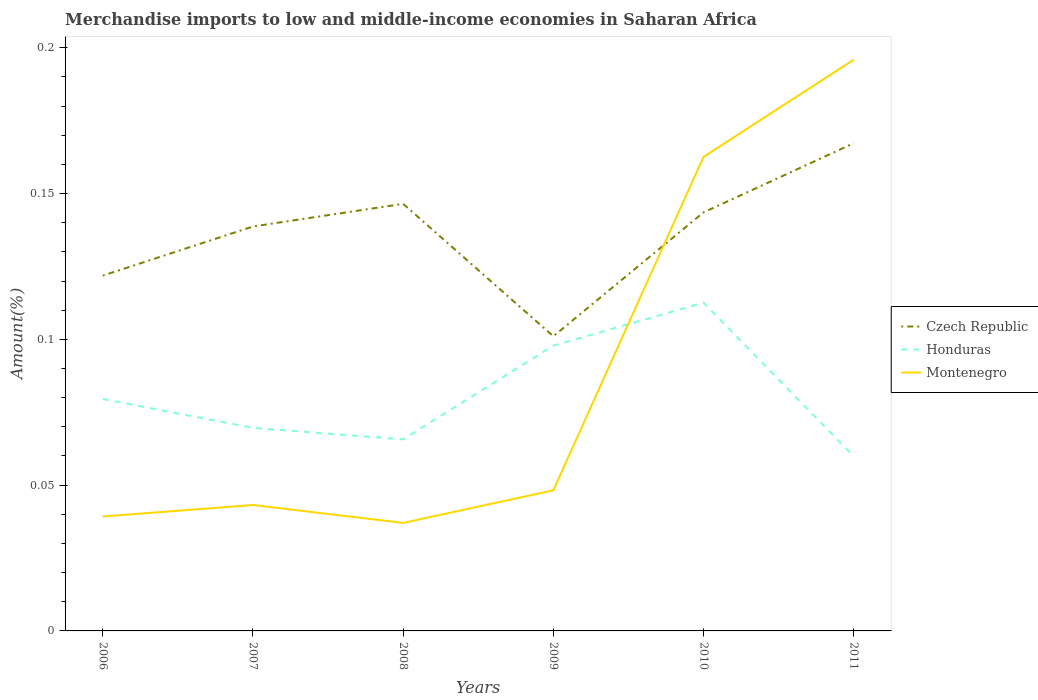How many different coloured lines are there?
Ensure brevity in your answer.  3. Across all years, what is the maximum percentage of amount earned from merchandise imports in Honduras?
Provide a short and direct response. 0.06. What is the total percentage of amount earned from merchandise imports in Czech Republic in the graph?
Your response must be concise. 0.05. What is the difference between the highest and the second highest percentage of amount earned from merchandise imports in Honduras?
Your answer should be compact. 0.05. What is the difference between the highest and the lowest percentage of amount earned from merchandise imports in Montenegro?
Your answer should be compact. 2. Is the percentage of amount earned from merchandise imports in Honduras strictly greater than the percentage of amount earned from merchandise imports in Montenegro over the years?
Ensure brevity in your answer.  No. How many lines are there?
Make the answer very short. 3. Are the values on the major ticks of Y-axis written in scientific E-notation?
Provide a succinct answer. No. Does the graph contain any zero values?
Give a very brief answer. No. Where does the legend appear in the graph?
Your response must be concise. Center right. How many legend labels are there?
Offer a very short reply. 3. How are the legend labels stacked?
Give a very brief answer. Vertical. What is the title of the graph?
Your answer should be very brief. Merchandise imports to low and middle-income economies in Saharan Africa. Does "Gambia, The" appear as one of the legend labels in the graph?
Provide a succinct answer. No. What is the label or title of the X-axis?
Provide a short and direct response. Years. What is the label or title of the Y-axis?
Your answer should be very brief. Amount(%). What is the Amount(%) in Czech Republic in 2006?
Make the answer very short. 0.12. What is the Amount(%) of Honduras in 2006?
Your response must be concise. 0.08. What is the Amount(%) in Montenegro in 2006?
Your response must be concise. 0.04. What is the Amount(%) of Czech Republic in 2007?
Provide a short and direct response. 0.14. What is the Amount(%) of Honduras in 2007?
Ensure brevity in your answer.  0.07. What is the Amount(%) in Montenegro in 2007?
Provide a succinct answer. 0.04. What is the Amount(%) of Czech Republic in 2008?
Your response must be concise. 0.15. What is the Amount(%) of Honduras in 2008?
Your answer should be compact. 0.07. What is the Amount(%) of Montenegro in 2008?
Offer a very short reply. 0.04. What is the Amount(%) of Czech Republic in 2009?
Keep it short and to the point. 0.1. What is the Amount(%) in Honduras in 2009?
Your answer should be compact. 0.1. What is the Amount(%) of Montenegro in 2009?
Your response must be concise. 0.05. What is the Amount(%) of Czech Republic in 2010?
Your answer should be very brief. 0.14. What is the Amount(%) in Honduras in 2010?
Provide a succinct answer. 0.11. What is the Amount(%) in Montenegro in 2010?
Give a very brief answer. 0.16. What is the Amount(%) in Czech Republic in 2011?
Provide a succinct answer. 0.17. What is the Amount(%) of Honduras in 2011?
Ensure brevity in your answer.  0.06. What is the Amount(%) of Montenegro in 2011?
Make the answer very short. 0.2. Across all years, what is the maximum Amount(%) of Czech Republic?
Give a very brief answer. 0.17. Across all years, what is the maximum Amount(%) of Honduras?
Offer a terse response. 0.11. Across all years, what is the maximum Amount(%) of Montenegro?
Ensure brevity in your answer.  0.2. Across all years, what is the minimum Amount(%) of Czech Republic?
Your answer should be very brief. 0.1. Across all years, what is the minimum Amount(%) in Honduras?
Provide a short and direct response. 0.06. Across all years, what is the minimum Amount(%) in Montenegro?
Give a very brief answer. 0.04. What is the total Amount(%) of Czech Republic in the graph?
Your response must be concise. 0.82. What is the total Amount(%) of Honduras in the graph?
Provide a succinct answer. 0.49. What is the total Amount(%) of Montenegro in the graph?
Your response must be concise. 0.53. What is the difference between the Amount(%) in Czech Republic in 2006 and that in 2007?
Your answer should be compact. -0.02. What is the difference between the Amount(%) in Honduras in 2006 and that in 2007?
Keep it short and to the point. 0.01. What is the difference between the Amount(%) of Montenegro in 2006 and that in 2007?
Provide a short and direct response. -0. What is the difference between the Amount(%) of Czech Republic in 2006 and that in 2008?
Provide a short and direct response. -0.02. What is the difference between the Amount(%) in Honduras in 2006 and that in 2008?
Provide a succinct answer. 0.01. What is the difference between the Amount(%) in Montenegro in 2006 and that in 2008?
Offer a terse response. 0. What is the difference between the Amount(%) in Czech Republic in 2006 and that in 2009?
Give a very brief answer. 0.02. What is the difference between the Amount(%) of Honduras in 2006 and that in 2009?
Give a very brief answer. -0.02. What is the difference between the Amount(%) in Montenegro in 2006 and that in 2009?
Your response must be concise. -0.01. What is the difference between the Amount(%) in Czech Republic in 2006 and that in 2010?
Ensure brevity in your answer.  -0.02. What is the difference between the Amount(%) of Honduras in 2006 and that in 2010?
Your answer should be very brief. -0.03. What is the difference between the Amount(%) of Montenegro in 2006 and that in 2010?
Give a very brief answer. -0.12. What is the difference between the Amount(%) of Czech Republic in 2006 and that in 2011?
Ensure brevity in your answer.  -0.05. What is the difference between the Amount(%) of Honduras in 2006 and that in 2011?
Your answer should be very brief. 0.02. What is the difference between the Amount(%) of Montenegro in 2006 and that in 2011?
Your answer should be compact. -0.16. What is the difference between the Amount(%) in Czech Republic in 2007 and that in 2008?
Make the answer very short. -0.01. What is the difference between the Amount(%) of Honduras in 2007 and that in 2008?
Your response must be concise. 0. What is the difference between the Amount(%) of Montenegro in 2007 and that in 2008?
Your answer should be compact. 0.01. What is the difference between the Amount(%) in Czech Republic in 2007 and that in 2009?
Provide a short and direct response. 0.04. What is the difference between the Amount(%) of Honduras in 2007 and that in 2009?
Provide a succinct answer. -0.03. What is the difference between the Amount(%) of Montenegro in 2007 and that in 2009?
Offer a terse response. -0.01. What is the difference between the Amount(%) in Czech Republic in 2007 and that in 2010?
Give a very brief answer. -0. What is the difference between the Amount(%) of Honduras in 2007 and that in 2010?
Your answer should be compact. -0.04. What is the difference between the Amount(%) of Montenegro in 2007 and that in 2010?
Offer a very short reply. -0.12. What is the difference between the Amount(%) in Czech Republic in 2007 and that in 2011?
Your answer should be very brief. -0.03. What is the difference between the Amount(%) in Honduras in 2007 and that in 2011?
Your response must be concise. 0.01. What is the difference between the Amount(%) of Montenegro in 2007 and that in 2011?
Ensure brevity in your answer.  -0.15. What is the difference between the Amount(%) in Czech Republic in 2008 and that in 2009?
Offer a very short reply. 0.05. What is the difference between the Amount(%) in Honduras in 2008 and that in 2009?
Provide a short and direct response. -0.03. What is the difference between the Amount(%) in Montenegro in 2008 and that in 2009?
Your response must be concise. -0.01. What is the difference between the Amount(%) of Czech Republic in 2008 and that in 2010?
Ensure brevity in your answer.  0. What is the difference between the Amount(%) of Honduras in 2008 and that in 2010?
Provide a succinct answer. -0.05. What is the difference between the Amount(%) in Montenegro in 2008 and that in 2010?
Keep it short and to the point. -0.13. What is the difference between the Amount(%) of Czech Republic in 2008 and that in 2011?
Offer a terse response. -0.02. What is the difference between the Amount(%) in Honduras in 2008 and that in 2011?
Ensure brevity in your answer.  0.01. What is the difference between the Amount(%) of Montenegro in 2008 and that in 2011?
Offer a terse response. -0.16. What is the difference between the Amount(%) of Czech Republic in 2009 and that in 2010?
Your answer should be very brief. -0.04. What is the difference between the Amount(%) of Honduras in 2009 and that in 2010?
Make the answer very short. -0.01. What is the difference between the Amount(%) of Montenegro in 2009 and that in 2010?
Provide a succinct answer. -0.11. What is the difference between the Amount(%) in Czech Republic in 2009 and that in 2011?
Your response must be concise. -0.07. What is the difference between the Amount(%) of Honduras in 2009 and that in 2011?
Make the answer very short. 0.04. What is the difference between the Amount(%) in Montenegro in 2009 and that in 2011?
Your answer should be very brief. -0.15. What is the difference between the Amount(%) in Czech Republic in 2010 and that in 2011?
Your answer should be very brief. -0.02. What is the difference between the Amount(%) in Honduras in 2010 and that in 2011?
Provide a succinct answer. 0.05. What is the difference between the Amount(%) of Montenegro in 2010 and that in 2011?
Give a very brief answer. -0.03. What is the difference between the Amount(%) of Czech Republic in 2006 and the Amount(%) of Honduras in 2007?
Offer a terse response. 0.05. What is the difference between the Amount(%) of Czech Republic in 2006 and the Amount(%) of Montenegro in 2007?
Your answer should be compact. 0.08. What is the difference between the Amount(%) of Honduras in 2006 and the Amount(%) of Montenegro in 2007?
Make the answer very short. 0.04. What is the difference between the Amount(%) of Czech Republic in 2006 and the Amount(%) of Honduras in 2008?
Offer a terse response. 0.06. What is the difference between the Amount(%) of Czech Republic in 2006 and the Amount(%) of Montenegro in 2008?
Keep it short and to the point. 0.08. What is the difference between the Amount(%) of Honduras in 2006 and the Amount(%) of Montenegro in 2008?
Ensure brevity in your answer.  0.04. What is the difference between the Amount(%) of Czech Republic in 2006 and the Amount(%) of Honduras in 2009?
Keep it short and to the point. 0.02. What is the difference between the Amount(%) in Czech Republic in 2006 and the Amount(%) in Montenegro in 2009?
Keep it short and to the point. 0.07. What is the difference between the Amount(%) of Honduras in 2006 and the Amount(%) of Montenegro in 2009?
Provide a succinct answer. 0.03. What is the difference between the Amount(%) in Czech Republic in 2006 and the Amount(%) in Honduras in 2010?
Make the answer very short. 0.01. What is the difference between the Amount(%) in Czech Republic in 2006 and the Amount(%) in Montenegro in 2010?
Give a very brief answer. -0.04. What is the difference between the Amount(%) in Honduras in 2006 and the Amount(%) in Montenegro in 2010?
Give a very brief answer. -0.08. What is the difference between the Amount(%) in Czech Republic in 2006 and the Amount(%) in Honduras in 2011?
Keep it short and to the point. 0.06. What is the difference between the Amount(%) in Czech Republic in 2006 and the Amount(%) in Montenegro in 2011?
Your answer should be very brief. -0.07. What is the difference between the Amount(%) in Honduras in 2006 and the Amount(%) in Montenegro in 2011?
Make the answer very short. -0.12. What is the difference between the Amount(%) of Czech Republic in 2007 and the Amount(%) of Honduras in 2008?
Make the answer very short. 0.07. What is the difference between the Amount(%) in Czech Republic in 2007 and the Amount(%) in Montenegro in 2008?
Your answer should be very brief. 0.1. What is the difference between the Amount(%) of Honduras in 2007 and the Amount(%) of Montenegro in 2008?
Offer a terse response. 0.03. What is the difference between the Amount(%) in Czech Republic in 2007 and the Amount(%) in Honduras in 2009?
Your answer should be compact. 0.04. What is the difference between the Amount(%) of Czech Republic in 2007 and the Amount(%) of Montenegro in 2009?
Your answer should be very brief. 0.09. What is the difference between the Amount(%) in Honduras in 2007 and the Amount(%) in Montenegro in 2009?
Provide a short and direct response. 0.02. What is the difference between the Amount(%) in Czech Republic in 2007 and the Amount(%) in Honduras in 2010?
Keep it short and to the point. 0.03. What is the difference between the Amount(%) of Czech Republic in 2007 and the Amount(%) of Montenegro in 2010?
Keep it short and to the point. -0.02. What is the difference between the Amount(%) in Honduras in 2007 and the Amount(%) in Montenegro in 2010?
Ensure brevity in your answer.  -0.09. What is the difference between the Amount(%) in Czech Republic in 2007 and the Amount(%) in Honduras in 2011?
Give a very brief answer. 0.08. What is the difference between the Amount(%) in Czech Republic in 2007 and the Amount(%) in Montenegro in 2011?
Make the answer very short. -0.06. What is the difference between the Amount(%) of Honduras in 2007 and the Amount(%) of Montenegro in 2011?
Make the answer very short. -0.13. What is the difference between the Amount(%) of Czech Republic in 2008 and the Amount(%) of Honduras in 2009?
Your response must be concise. 0.05. What is the difference between the Amount(%) of Czech Republic in 2008 and the Amount(%) of Montenegro in 2009?
Your answer should be compact. 0.1. What is the difference between the Amount(%) in Honduras in 2008 and the Amount(%) in Montenegro in 2009?
Provide a short and direct response. 0.02. What is the difference between the Amount(%) in Czech Republic in 2008 and the Amount(%) in Honduras in 2010?
Ensure brevity in your answer.  0.03. What is the difference between the Amount(%) of Czech Republic in 2008 and the Amount(%) of Montenegro in 2010?
Your answer should be compact. -0.02. What is the difference between the Amount(%) in Honduras in 2008 and the Amount(%) in Montenegro in 2010?
Provide a succinct answer. -0.1. What is the difference between the Amount(%) in Czech Republic in 2008 and the Amount(%) in Honduras in 2011?
Your answer should be compact. 0.09. What is the difference between the Amount(%) of Czech Republic in 2008 and the Amount(%) of Montenegro in 2011?
Make the answer very short. -0.05. What is the difference between the Amount(%) in Honduras in 2008 and the Amount(%) in Montenegro in 2011?
Keep it short and to the point. -0.13. What is the difference between the Amount(%) in Czech Republic in 2009 and the Amount(%) in Honduras in 2010?
Make the answer very short. -0.01. What is the difference between the Amount(%) in Czech Republic in 2009 and the Amount(%) in Montenegro in 2010?
Your answer should be compact. -0.06. What is the difference between the Amount(%) of Honduras in 2009 and the Amount(%) of Montenegro in 2010?
Make the answer very short. -0.06. What is the difference between the Amount(%) of Czech Republic in 2009 and the Amount(%) of Honduras in 2011?
Offer a terse response. 0.04. What is the difference between the Amount(%) in Czech Republic in 2009 and the Amount(%) in Montenegro in 2011?
Keep it short and to the point. -0.09. What is the difference between the Amount(%) in Honduras in 2009 and the Amount(%) in Montenegro in 2011?
Provide a succinct answer. -0.1. What is the difference between the Amount(%) of Czech Republic in 2010 and the Amount(%) of Honduras in 2011?
Ensure brevity in your answer.  0.08. What is the difference between the Amount(%) of Czech Republic in 2010 and the Amount(%) of Montenegro in 2011?
Ensure brevity in your answer.  -0.05. What is the difference between the Amount(%) in Honduras in 2010 and the Amount(%) in Montenegro in 2011?
Ensure brevity in your answer.  -0.08. What is the average Amount(%) of Czech Republic per year?
Provide a short and direct response. 0.14. What is the average Amount(%) in Honduras per year?
Provide a short and direct response. 0.08. What is the average Amount(%) in Montenegro per year?
Your response must be concise. 0.09. In the year 2006, what is the difference between the Amount(%) of Czech Republic and Amount(%) of Honduras?
Offer a terse response. 0.04. In the year 2006, what is the difference between the Amount(%) of Czech Republic and Amount(%) of Montenegro?
Offer a very short reply. 0.08. In the year 2006, what is the difference between the Amount(%) of Honduras and Amount(%) of Montenegro?
Keep it short and to the point. 0.04. In the year 2007, what is the difference between the Amount(%) in Czech Republic and Amount(%) in Honduras?
Make the answer very short. 0.07. In the year 2007, what is the difference between the Amount(%) of Czech Republic and Amount(%) of Montenegro?
Offer a very short reply. 0.1. In the year 2007, what is the difference between the Amount(%) in Honduras and Amount(%) in Montenegro?
Your answer should be very brief. 0.03. In the year 2008, what is the difference between the Amount(%) of Czech Republic and Amount(%) of Honduras?
Keep it short and to the point. 0.08. In the year 2008, what is the difference between the Amount(%) of Czech Republic and Amount(%) of Montenegro?
Your answer should be compact. 0.11. In the year 2008, what is the difference between the Amount(%) of Honduras and Amount(%) of Montenegro?
Make the answer very short. 0.03. In the year 2009, what is the difference between the Amount(%) in Czech Republic and Amount(%) in Honduras?
Ensure brevity in your answer.  0. In the year 2009, what is the difference between the Amount(%) of Czech Republic and Amount(%) of Montenegro?
Your response must be concise. 0.05. In the year 2009, what is the difference between the Amount(%) of Honduras and Amount(%) of Montenegro?
Your answer should be very brief. 0.05. In the year 2010, what is the difference between the Amount(%) in Czech Republic and Amount(%) in Honduras?
Keep it short and to the point. 0.03. In the year 2010, what is the difference between the Amount(%) in Czech Republic and Amount(%) in Montenegro?
Make the answer very short. -0.02. In the year 2010, what is the difference between the Amount(%) of Honduras and Amount(%) of Montenegro?
Ensure brevity in your answer.  -0.05. In the year 2011, what is the difference between the Amount(%) of Czech Republic and Amount(%) of Honduras?
Provide a short and direct response. 0.11. In the year 2011, what is the difference between the Amount(%) in Czech Republic and Amount(%) in Montenegro?
Ensure brevity in your answer.  -0.03. In the year 2011, what is the difference between the Amount(%) of Honduras and Amount(%) of Montenegro?
Keep it short and to the point. -0.14. What is the ratio of the Amount(%) in Czech Republic in 2006 to that in 2007?
Your answer should be very brief. 0.88. What is the ratio of the Amount(%) of Honduras in 2006 to that in 2007?
Make the answer very short. 1.14. What is the ratio of the Amount(%) of Montenegro in 2006 to that in 2007?
Provide a short and direct response. 0.91. What is the ratio of the Amount(%) of Czech Republic in 2006 to that in 2008?
Keep it short and to the point. 0.83. What is the ratio of the Amount(%) in Honduras in 2006 to that in 2008?
Your answer should be very brief. 1.21. What is the ratio of the Amount(%) of Montenegro in 2006 to that in 2008?
Make the answer very short. 1.06. What is the ratio of the Amount(%) in Czech Republic in 2006 to that in 2009?
Your answer should be very brief. 1.21. What is the ratio of the Amount(%) in Honduras in 2006 to that in 2009?
Offer a terse response. 0.81. What is the ratio of the Amount(%) in Montenegro in 2006 to that in 2009?
Your answer should be compact. 0.81. What is the ratio of the Amount(%) in Czech Republic in 2006 to that in 2010?
Give a very brief answer. 0.85. What is the ratio of the Amount(%) in Honduras in 2006 to that in 2010?
Your response must be concise. 0.71. What is the ratio of the Amount(%) of Montenegro in 2006 to that in 2010?
Provide a short and direct response. 0.24. What is the ratio of the Amount(%) in Czech Republic in 2006 to that in 2011?
Offer a terse response. 0.73. What is the ratio of the Amount(%) of Honduras in 2006 to that in 2011?
Your response must be concise. 1.33. What is the ratio of the Amount(%) of Montenegro in 2006 to that in 2011?
Keep it short and to the point. 0.2. What is the ratio of the Amount(%) in Czech Republic in 2007 to that in 2008?
Give a very brief answer. 0.95. What is the ratio of the Amount(%) in Honduras in 2007 to that in 2008?
Keep it short and to the point. 1.06. What is the ratio of the Amount(%) of Montenegro in 2007 to that in 2008?
Keep it short and to the point. 1.17. What is the ratio of the Amount(%) in Czech Republic in 2007 to that in 2009?
Ensure brevity in your answer.  1.37. What is the ratio of the Amount(%) of Honduras in 2007 to that in 2009?
Offer a terse response. 0.71. What is the ratio of the Amount(%) in Montenegro in 2007 to that in 2009?
Make the answer very short. 0.9. What is the ratio of the Amount(%) of Czech Republic in 2007 to that in 2010?
Keep it short and to the point. 0.97. What is the ratio of the Amount(%) in Honduras in 2007 to that in 2010?
Offer a terse response. 0.62. What is the ratio of the Amount(%) in Montenegro in 2007 to that in 2010?
Your answer should be compact. 0.27. What is the ratio of the Amount(%) of Czech Republic in 2007 to that in 2011?
Offer a terse response. 0.83. What is the ratio of the Amount(%) of Honduras in 2007 to that in 2011?
Your answer should be very brief. 1.16. What is the ratio of the Amount(%) in Montenegro in 2007 to that in 2011?
Make the answer very short. 0.22. What is the ratio of the Amount(%) of Czech Republic in 2008 to that in 2009?
Your response must be concise. 1.45. What is the ratio of the Amount(%) in Honduras in 2008 to that in 2009?
Ensure brevity in your answer.  0.67. What is the ratio of the Amount(%) of Montenegro in 2008 to that in 2009?
Ensure brevity in your answer.  0.77. What is the ratio of the Amount(%) of Czech Republic in 2008 to that in 2010?
Your answer should be very brief. 1.02. What is the ratio of the Amount(%) in Honduras in 2008 to that in 2010?
Provide a succinct answer. 0.58. What is the ratio of the Amount(%) of Montenegro in 2008 to that in 2010?
Your response must be concise. 0.23. What is the ratio of the Amount(%) of Czech Republic in 2008 to that in 2011?
Provide a short and direct response. 0.88. What is the ratio of the Amount(%) of Honduras in 2008 to that in 2011?
Your answer should be compact. 1.1. What is the ratio of the Amount(%) in Montenegro in 2008 to that in 2011?
Your response must be concise. 0.19. What is the ratio of the Amount(%) in Czech Republic in 2009 to that in 2010?
Offer a very short reply. 0.7. What is the ratio of the Amount(%) of Honduras in 2009 to that in 2010?
Your answer should be compact. 0.87. What is the ratio of the Amount(%) of Montenegro in 2009 to that in 2010?
Make the answer very short. 0.3. What is the ratio of the Amount(%) of Czech Republic in 2009 to that in 2011?
Provide a short and direct response. 0.6. What is the ratio of the Amount(%) in Honduras in 2009 to that in 2011?
Offer a terse response. 1.63. What is the ratio of the Amount(%) of Montenegro in 2009 to that in 2011?
Make the answer very short. 0.25. What is the ratio of the Amount(%) in Czech Republic in 2010 to that in 2011?
Provide a short and direct response. 0.86. What is the ratio of the Amount(%) in Honduras in 2010 to that in 2011?
Give a very brief answer. 1.88. What is the ratio of the Amount(%) in Montenegro in 2010 to that in 2011?
Your answer should be very brief. 0.83. What is the difference between the highest and the second highest Amount(%) in Czech Republic?
Your response must be concise. 0.02. What is the difference between the highest and the second highest Amount(%) in Honduras?
Your response must be concise. 0.01. What is the difference between the highest and the lowest Amount(%) of Czech Republic?
Your response must be concise. 0.07. What is the difference between the highest and the lowest Amount(%) of Honduras?
Offer a terse response. 0.05. What is the difference between the highest and the lowest Amount(%) in Montenegro?
Keep it short and to the point. 0.16. 